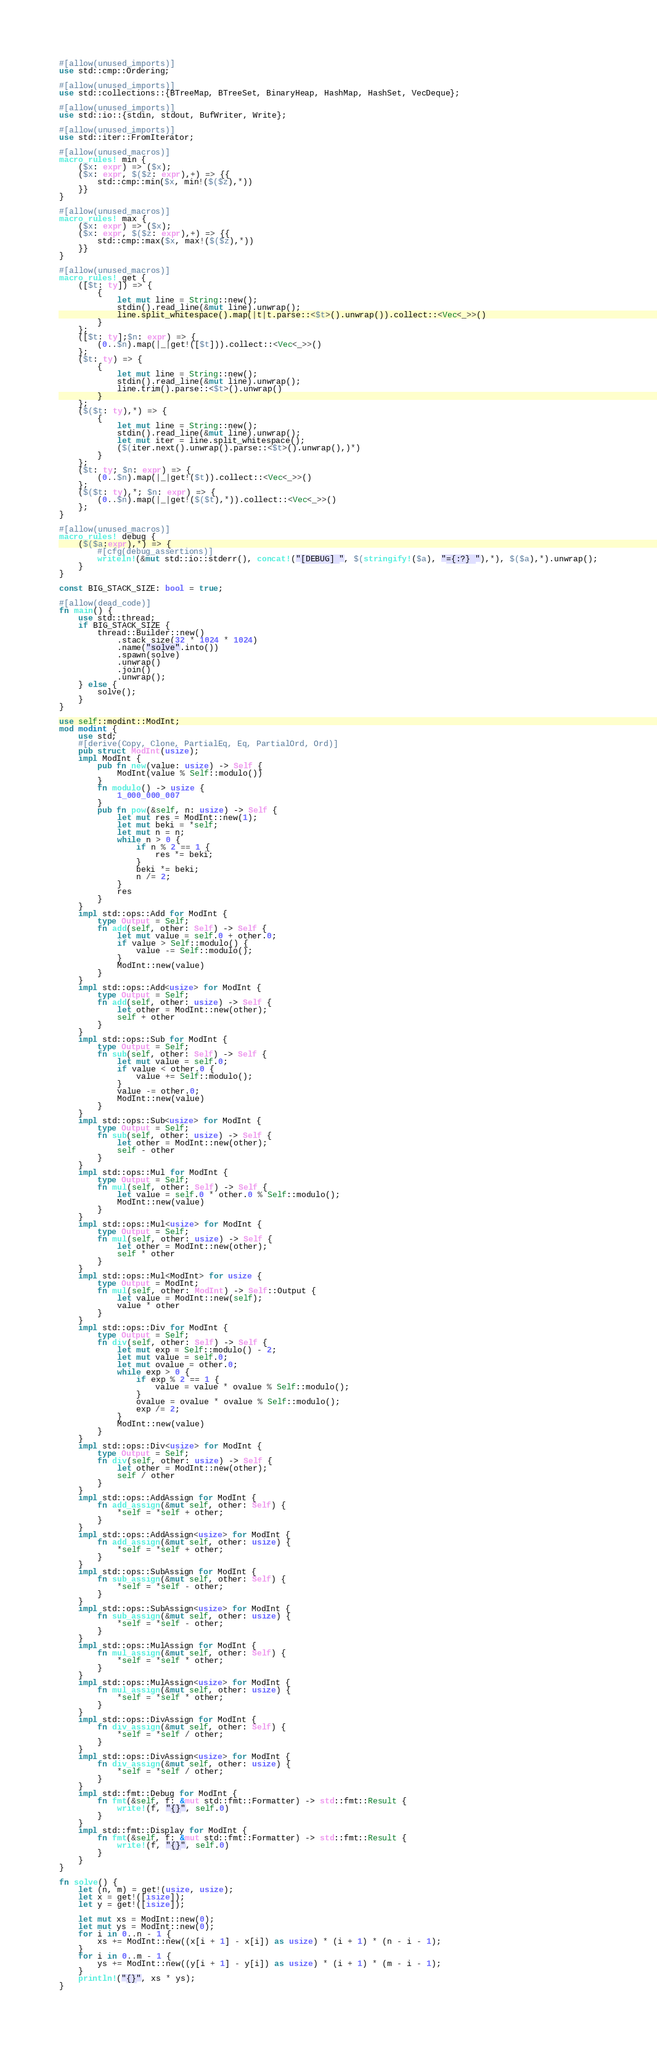<code> <loc_0><loc_0><loc_500><loc_500><_Rust_>#[allow(unused_imports)]
use std::cmp::Ordering;

#[allow(unused_imports)]
use std::collections::{BTreeMap, BTreeSet, BinaryHeap, HashMap, HashSet, VecDeque};

#[allow(unused_imports)]
use std::io::{stdin, stdout, BufWriter, Write};

#[allow(unused_imports)]
use std::iter::FromIterator;

#[allow(unused_macros)]
macro_rules! min {
    ($x: expr) => ($x);
    ($x: expr, $($z: expr),+) => {{
        std::cmp::min($x, min!($($z),*))
    }}
}

#[allow(unused_macros)]
macro_rules! max {
    ($x: expr) => ($x);
    ($x: expr, $($z: expr),+) => {{
        std::cmp::max($x, max!($($z),*))
    }}
}

#[allow(unused_macros)]
macro_rules! get {
    ([$t: ty]) => {
        {
            let mut line = String::new();
            stdin().read_line(&mut line).unwrap();
            line.split_whitespace().map(|t|t.parse::<$t>().unwrap()).collect::<Vec<_>>()
        }
    };
    ([$t: ty];$n: expr) => {
        (0..$n).map(|_|get!([$t])).collect::<Vec<_>>()
    };
    ($t: ty) => {
        {
            let mut line = String::new();
            stdin().read_line(&mut line).unwrap();
            line.trim().parse::<$t>().unwrap()
        }
    };
    ($($t: ty),*) => {
        {
            let mut line = String::new();
            stdin().read_line(&mut line).unwrap();
            let mut iter = line.split_whitespace();
            ($(iter.next().unwrap().parse::<$t>().unwrap(),)*)
        }
    };
    ($t: ty; $n: expr) => {
        (0..$n).map(|_|get!($t)).collect::<Vec<_>>()
    };
    ($($t: ty),*; $n: expr) => {
        (0..$n).map(|_|get!($($t),*)).collect::<Vec<_>>()
    };
}

#[allow(unused_macros)]
macro_rules! debug {
    ($($a:expr),*) => {
        #[cfg(debug_assertions)]
        writeln!(&mut std::io::stderr(), concat!("[DEBUG] ", $(stringify!($a), "={:?} "),*), $($a),*).unwrap();
    }
}

const BIG_STACK_SIZE: bool = true;

#[allow(dead_code)]
fn main() {
    use std::thread;
    if BIG_STACK_SIZE {
        thread::Builder::new()
            .stack_size(32 * 1024 * 1024)
            .name("solve".into())
            .spawn(solve)
            .unwrap()
            .join()
            .unwrap();
    } else {
        solve();
    }
}

use self::modint::ModInt;
mod modint {
    use std;
    #[derive(Copy, Clone, PartialEq, Eq, PartialOrd, Ord)]
    pub struct ModInt(usize);
    impl ModInt {
        pub fn new(value: usize) -> Self {
            ModInt(value % Self::modulo())
        }
        fn modulo() -> usize {
            1_000_000_007
        }
        pub fn pow(&self, n: usize) -> Self {
            let mut res = ModInt::new(1);
            let mut beki = *self;
            let mut n = n;
            while n > 0 {
                if n % 2 == 1 {
                    res *= beki;
                }
                beki *= beki;
                n /= 2;
            }
            res
        }
    }
    impl std::ops::Add for ModInt {
        type Output = Self;
        fn add(self, other: Self) -> Self {
            let mut value = self.0 + other.0;
            if value > Self::modulo() {
                value -= Self::modulo();
            }
            ModInt::new(value)
        }
    }
    impl std::ops::Add<usize> for ModInt {
        type Output = Self;
        fn add(self, other: usize) -> Self {
            let other = ModInt::new(other);
            self + other
        }
    }
    impl std::ops::Sub for ModInt {
        type Output = Self;
        fn sub(self, other: Self) -> Self {
            let mut value = self.0;
            if value < other.0 {
                value += Self::modulo();
            }
            value -= other.0;
            ModInt::new(value)
        }
    }
    impl std::ops::Sub<usize> for ModInt {
        type Output = Self;
        fn sub(self, other: usize) -> Self {
            let other = ModInt::new(other);
            self - other
        }
    }
    impl std::ops::Mul for ModInt {
        type Output = Self;
        fn mul(self, other: Self) -> Self {
            let value = self.0 * other.0 % Self::modulo();
            ModInt::new(value)
        }
    }
    impl std::ops::Mul<usize> for ModInt {
        type Output = Self;
        fn mul(self, other: usize) -> Self {
            let other = ModInt::new(other);
            self * other
        }
    }
    impl std::ops::Mul<ModInt> for usize {
        type Output = ModInt;
        fn mul(self, other: ModInt) -> Self::Output {
            let value = ModInt::new(self);
            value * other
        }
    }
    impl std::ops::Div for ModInt {
        type Output = Self;
        fn div(self, other: Self) -> Self {
            let mut exp = Self::modulo() - 2;
            let mut value = self.0;
            let mut ovalue = other.0;
            while exp > 0 {
                if exp % 2 == 1 {
                    value = value * ovalue % Self::modulo();
                }
                ovalue = ovalue * ovalue % Self::modulo();
                exp /= 2;
            }
            ModInt::new(value)
        }
    }
    impl std::ops::Div<usize> for ModInt {
        type Output = Self;
        fn div(self, other: usize) -> Self {
            let other = ModInt::new(other);
            self / other
        }
    }
    impl std::ops::AddAssign for ModInt {
        fn add_assign(&mut self, other: Self) {
            *self = *self + other;
        }
    }
    impl std::ops::AddAssign<usize> for ModInt {
        fn add_assign(&mut self, other: usize) {
            *self = *self + other;
        }
    }
    impl std::ops::SubAssign for ModInt {
        fn sub_assign(&mut self, other: Self) {
            *self = *self - other;
        }
    }
    impl std::ops::SubAssign<usize> for ModInt {
        fn sub_assign(&mut self, other: usize) {
            *self = *self - other;
        }
    }
    impl std::ops::MulAssign for ModInt {
        fn mul_assign(&mut self, other: Self) {
            *self = *self * other;
        }
    }
    impl std::ops::MulAssign<usize> for ModInt {
        fn mul_assign(&mut self, other: usize) {
            *self = *self * other;
        }
    }
    impl std::ops::DivAssign for ModInt {
        fn div_assign(&mut self, other: Self) {
            *self = *self / other;
        }
    }
    impl std::ops::DivAssign<usize> for ModInt {
        fn div_assign(&mut self, other: usize) {
            *self = *self / other;
        }
    }
    impl std::fmt::Debug for ModInt {
        fn fmt(&self, f: &mut std::fmt::Formatter) -> std::fmt::Result {
            write!(f, "{}", self.0)
        }
    }
    impl std::fmt::Display for ModInt {
        fn fmt(&self, f: &mut std::fmt::Formatter) -> std::fmt::Result {
            write!(f, "{}", self.0)
        }
    }
}

fn solve() {
    let (n, m) = get!(usize, usize);
    let x = get!([isize]);
    let y = get!([isize]);

    let mut xs = ModInt::new(0);
    let mut ys = ModInt::new(0);
    for i in 0..n - 1 {
        xs += ModInt::new((x[i + 1] - x[i]) as usize) * (i + 1) * (n - i - 1);
    }
    for i in 0..m - 1 {
        ys += ModInt::new((y[i + 1] - y[i]) as usize) * (i + 1) * (m - i - 1);
    }
    println!("{}", xs * ys);
}
</code> 